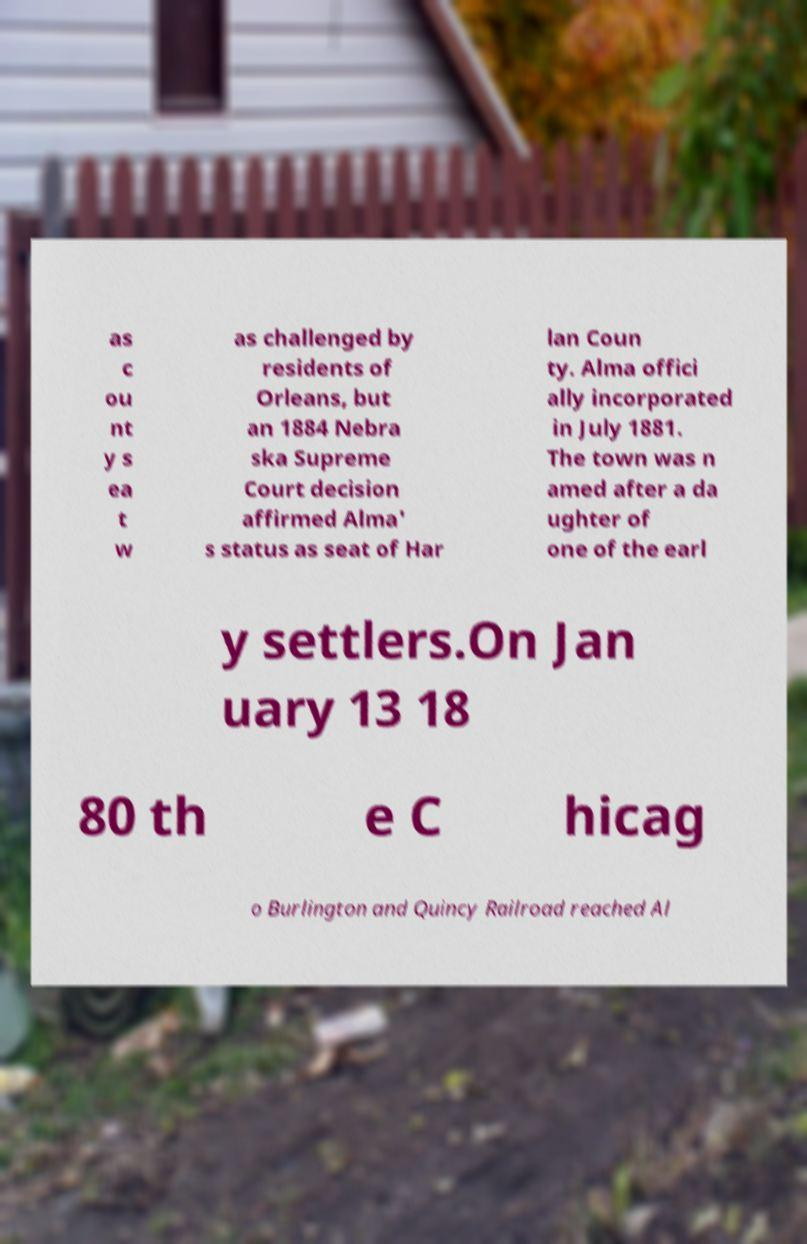Can you read and provide the text displayed in the image?This photo seems to have some interesting text. Can you extract and type it out for me? as c ou nt y s ea t w as challenged by residents of Orleans, but an 1884 Nebra ska Supreme Court decision affirmed Alma' s status as seat of Har lan Coun ty. Alma offici ally incorporated in July 1881. The town was n amed after a da ughter of one of the earl y settlers.On Jan uary 13 18 80 th e C hicag o Burlington and Quincy Railroad reached Al 